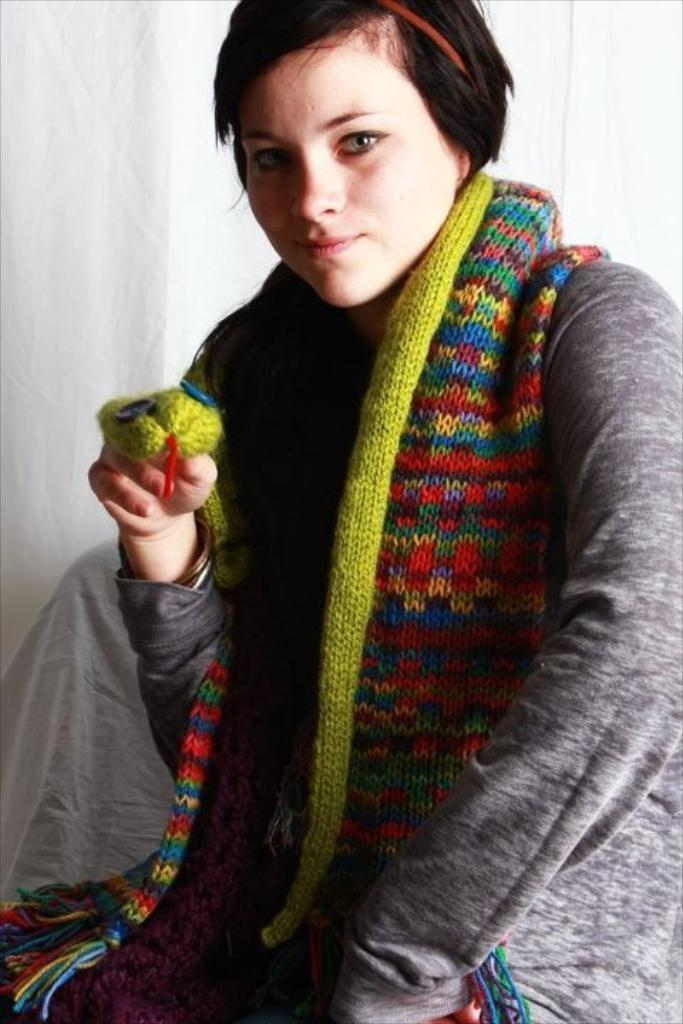What is present in the image? There is a person in the image. Can you describe the person's clothing? The person is wearing a dress with gray, green, and red colors. What color is the background of the image? The background of the image is white. What type of leather material can be seen on the person's clothing in the image? There is no leather material present on the person's clothing in the image. Can you hear any bells ringing in the image? There are no bells or sounds present in the image, as it is a still photograph. 